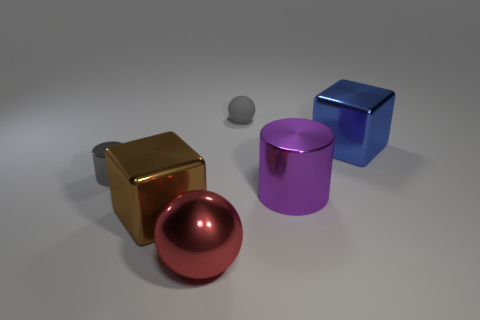Add 4 big brown objects. How many objects exist? 10 Subtract all gray cylinders. How many cylinders are left? 1 Subtract all gray blocks. How many gray spheres are left? 1 Subtract all tiny shiny cylinders. Subtract all tiny cyan shiny balls. How many objects are left? 5 Add 6 spheres. How many spheres are left? 8 Add 1 tiny metal cylinders. How many tiny metal cylinders exist? 2 Subtract 0 cyan spheres. How many objects are left? 6 Subtract all blocks. How many objects are left? 4 Subtract 1 blocks. How many blocks are left? 1 Subtract all green cylinders. Subtract all brown balls. How many cylinders are left? 2 